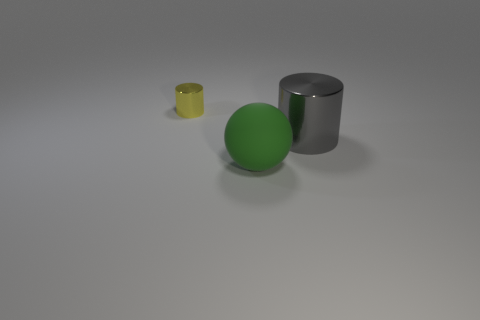Add 2 small yellow metallic objects. How many objects exist? 5 Subtract all balls. How many objects are left? 2 Subtract all cyan matte cylinders. Subtract all small yellow shiny cylinders. How many objects are left? 2 Add 3 metallic cylinders. How many metallic cylinders are left? 5 Add 3 large red matte blocks. How many large red matte blocks exist? 3 Subtract 0 purple cylinders. How many objects are left? 3 